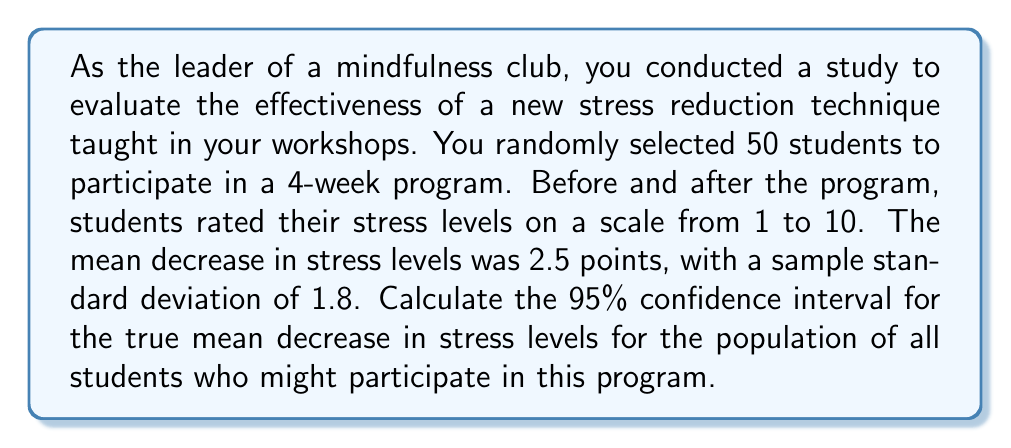Show me your answer to this math problem. To calculate the confidence interval, we'll use the formula:

$$ \text{CI} = \bar{x} \pm t_{\alpha/2, n-1} \cdot \frac{s}{\sqrt{n}} $$

Where:
$\bar{x}$ = sample mean
$t_{\alpha/2, n-1}$ = t-value for 95% confidence level with n-1 degrees of freedom
$s$ = sample standard deviation
$n$ = sample size

Step 1: Identify the known values
$\bar{x} = 2.5$
$s = 1.8$
$n = 50$
Confidence level = 95% (α = 0.05)

Step 2: Find the t-value
For a 95% confidence interval with 49 degrees of freedom (n-1 = 50-1 = 49), the t-value is approximately 2.009 (from t-distribution table).

Step 3: Calculate the margin of error
$$ \text{Margin of Error} = t_{\alpha/2, n-1} \cdot \frac{s}{\sqrt{n}} = 2.009 \cdot \frac{1.8}{\sqrt{50}} \approx 0.511 $$

Step 4: Calculate the confidence interval
Lower bound: $2.5 - 0.511 = 1.989$
Upper bound: $2.5 + 0.511 = 3.011$

Therefore, the 95% confidence interval for the true mean decrease in stress levels is (1.989, 3.011).
Answer: (1.989, 3.011) 